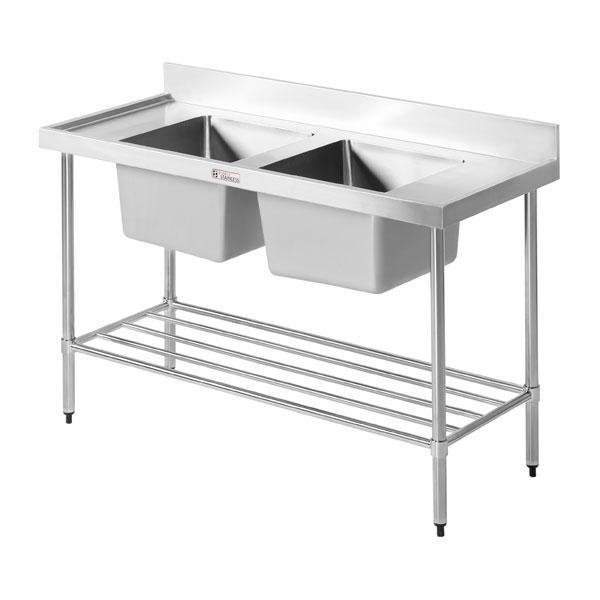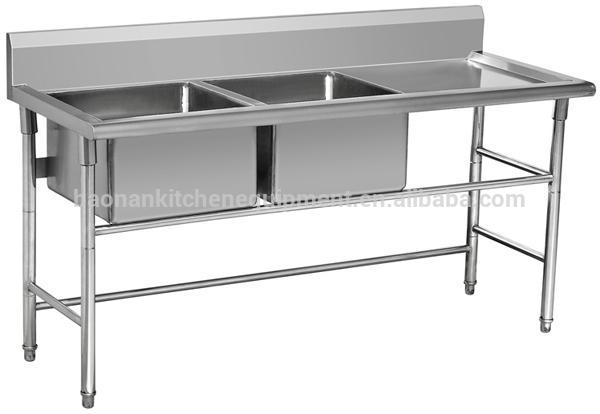The first image is the image on the left, the second image is the image on the right. Examine the images to the left and right. Is the description "There is a double sink with a slotted storage rack under it" accurate? Answer yes or no. Yes. The first image is the image on the left, the second image is the image on the right. For the images shown, is this caption "Design features present in the combined images include a railed lower shelf, and extra open space on the right of two stainless steel sinks in one unit." true? Answer yes or no. Yes. 